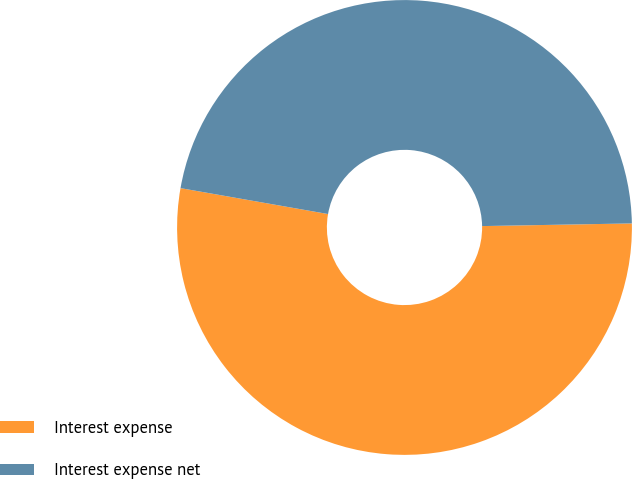Convert chart to OTSL. <chart><loc_0><loc_0><loc_500><loc_500><pie_chart><fcel>Interest expense<fcel>Interest expense net<nl><fcel>53.05%<fcel>46.95%<nl></chart> 